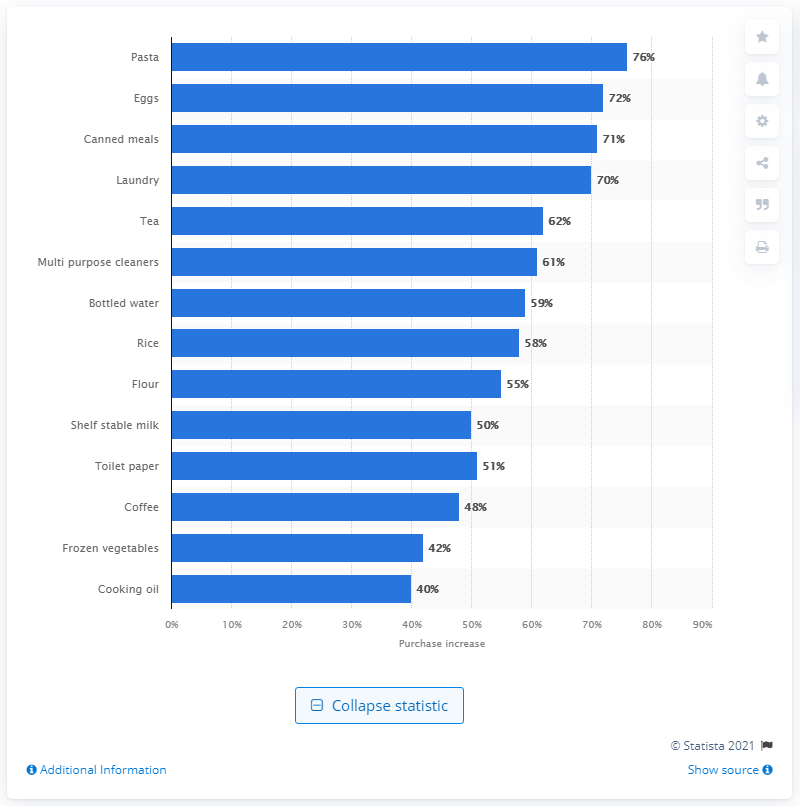Draw attention to some important aspects in this diagram. Online purchases of pasta in Australia increased by 76% during the four weeks leading up to February 22, 2020. In February of 2020, there was a significant increase in the number of eggs sold online in Australia compared to the previous year. Specifically, 72% more eggs were sold online in February 2020 compared to February 2019. 